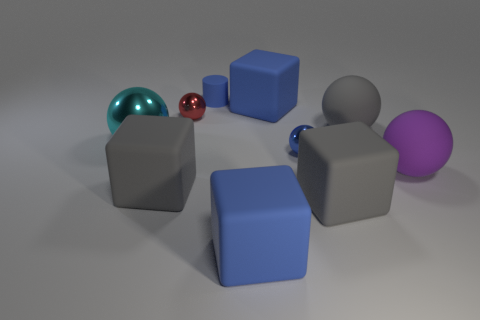Subtract all big matte spheres. How many spheres are left? 3 Subtract all gray cubes. How many cubes are left? 2 Subtract 1 cubes. How many cubes are left? 3 Subtract all cubes. How many objects are left? 6 Subtract 0 yellow balls. How many objects are left? 10 Subtract all cyan spheres. Subtract all blue blocks. How many spheres are left? 4 Subtract all gray balls. How many gray blocks are left? 2 Subtract all blue matte cubes. Subtract all big spheres. How many objects are left? 5 Add 4 large rubber balls. How many large rubber balls are left? 6 Add 6 gray matte things. How many gray matte things exist? 9 